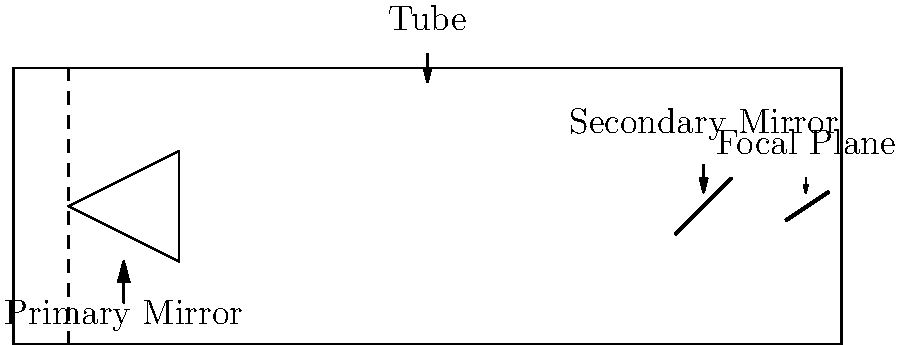In the cross-section view of a reflecting telescope shown above, which component is responsible for collecting and focusing the majority of incoming light? To answer this question, let's examine the main components of a reflecting telescope:

1. Tube: This is the outer structure that houses all the optical components. It doesn't collect or focus light itself.

2. Primary Mirror: This is the large, curved mirror at the bottom of the telescope. Its primary function is to collect and focus incoming light.

3. Secondary Mirror: This smaller mirror near the top of the telescope redirects the focused light from the primary mirror.

4. Focal Plane: This is where the image is formed and where detectors or eyepieces are placed.

The component responsible for collecting and focusing the majority of incoming light is the Primary Mirror. It has the largest surface area and is specifically designed to gather light from distant celestial objects and focus it to a point. The other components play supporting roles in the telescope's operation, but the primary mirror is the main light-gathering element.
Answer: Primary Mirror 